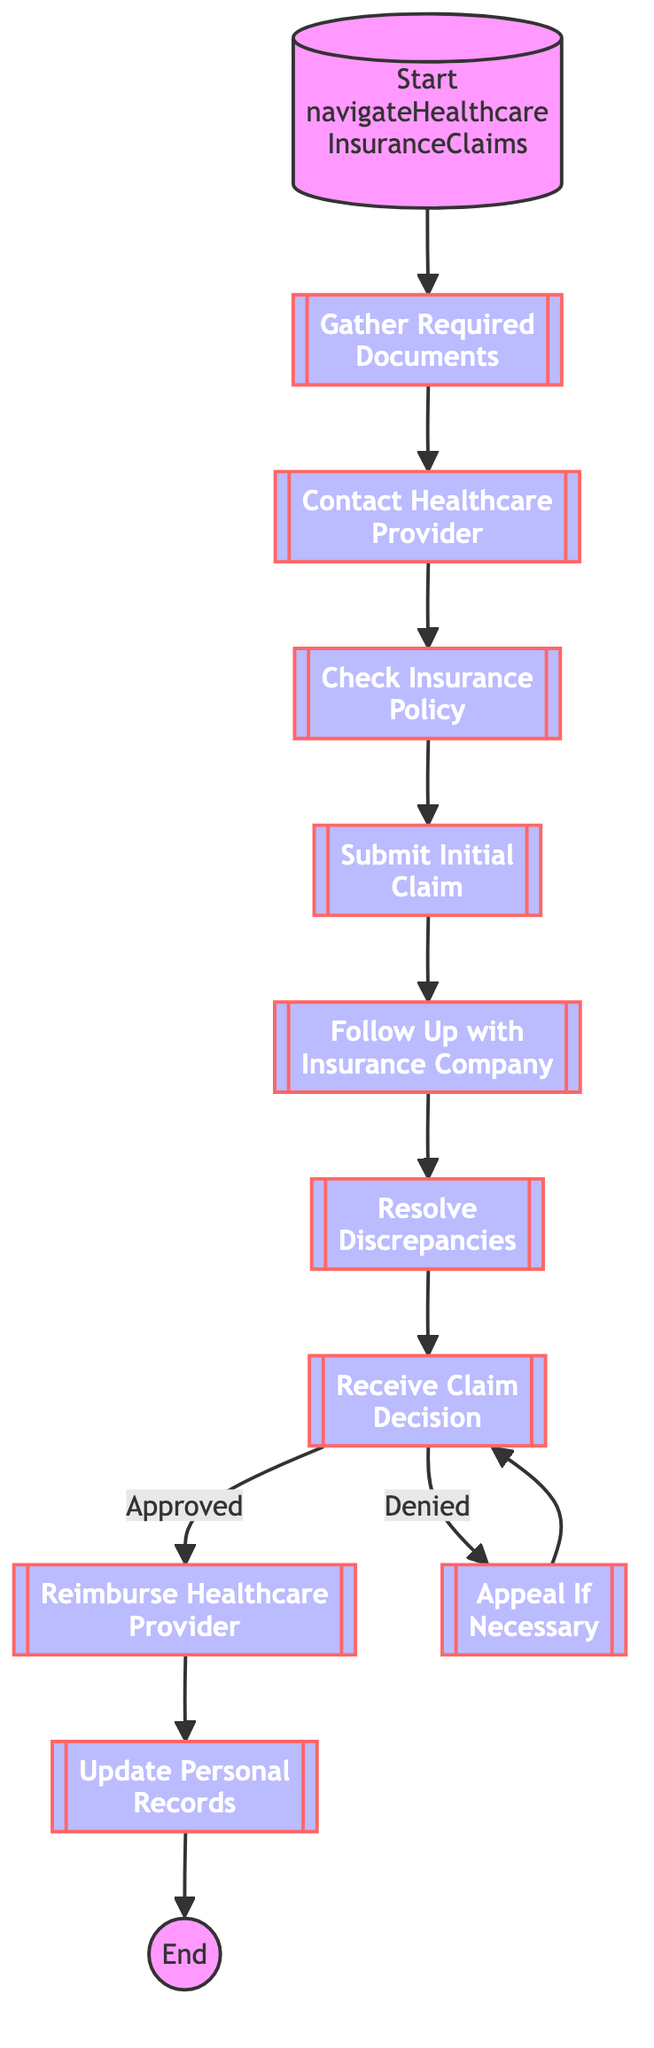What are the first two steps in the process? The first two steps in the diagram are "Gather Required Documents" and "Contact Healthcare Provider". Following the flow from the Start node, the arrows lead to these two nodes sequentially, indicating they are the first actions to take.
Answer: Gather Required Documents, Contact Healthcare Provider How many decisions are present in the diagram? The diagram contains one decision point located at "Receive Claim Decision", leading to two branches for approved and denied claims. This is the only place where a decision affects the flow, indicating two potential outcomes.
Answer: 1 What is the last step after reimbursement? The last step after reimbursement is "Update Personal Records". Following the reimbursement step, the flowchart indicates that this step is necessary to maintain accurate records of the claims process.
Answer: Update Personal Records What should you do if the claim is denied? If the claim is denied, the next step is to "Appeal If Necessary". The flowchart directs the user from the denied outcome back to the appeal process, indicating a corrective action is needed.
Answer: Appeal If Necessary How many steps are there before receiving a claim decision? There are seven steps before reaching the "Receive Claim Decision". The sequence includes gathering documents, contacting providers, checking the policy, submitting the claim, and following up, then resolving discrepancies leads to this decision point.
Answer: 7 What is required before you can submit an initial claim? Before submitting an initial claim, it's required to "Check Insurance Policy". The flowchart shows that this step, which involves reviewing the coverage details, comes before any submission can occur.
Answer: Check Insurance Policy Which step follows after resolving discrepancies? The step that follows after "Resolve Discrepancies" is "Receive Claim Decision". The flowchart indicates a direct progression from addressing any issues to awaiting the insurance company's decision.
Answer: Receive Claim Decision 